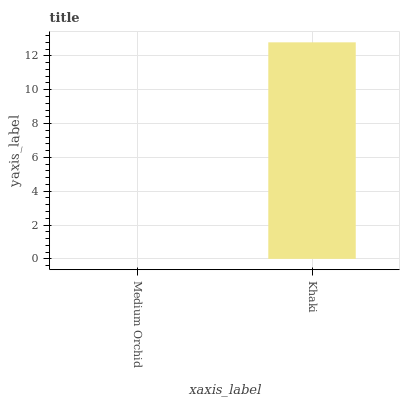Is Medium Orchid the minimum?
Answer yes or no. Yes. Is Khaki the maximum?
Answer yes or no. Yes. Is Khaki the minimum?
Answer yes or no. No. Is Khaki greater than Medium Orchid?
Answer yes or no. Yes. Is Medium Orchid less than Khaki?
Answer yes or no. Yes. Is Medium Orchid greater than Khaki?
Answer yes or no. No. Is Khaki less than Medium Orchid?
Answer yes or no. No. Is Khaki the high median?
Answer yes or no. Yes. Is Medium Orchid the low median?
Answer yes or no. Yes. Is Medium Orchid the high median?
Answer yes or no. No. Is Khaki the low median?
Answer yes or no. No. 